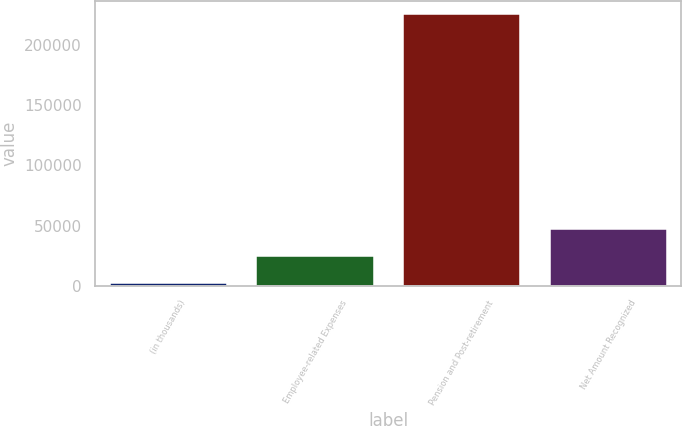Convert chart to OTSL. <chart><loc_0><loc_0><loc_500><loc_500><bar_chart><fcel>(in thousands)<fcel>Employee-related Expenses<fcel>Pension and Post-retirement<fcel>Net Amount Recognized<nl><fcel>2018<fcel>24398.7<fcel>225825<fcel>46779.4<nl></chart> 